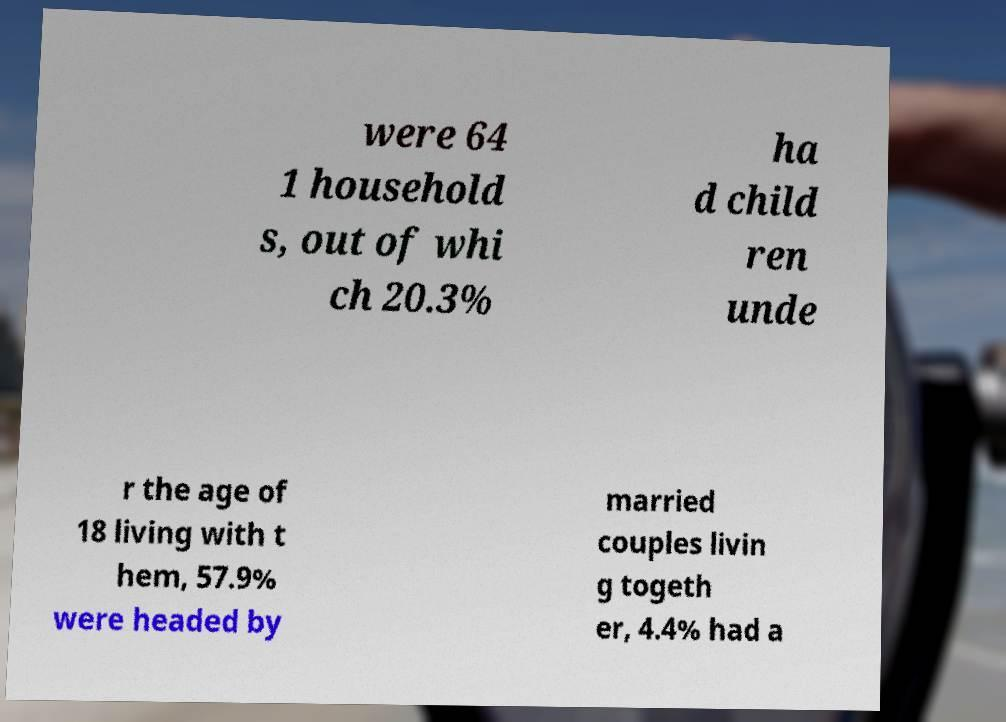Can you read and provide the text displayed in the image?This photo seems to have some interesting text. Can you extract and type it out for me? were 64 1 household s, out of whi ch 20.3% ha d child ren unde r the age of 18 living with t hem, 57.9% were headed by married couples livin g togeth er, 4.4% had a 